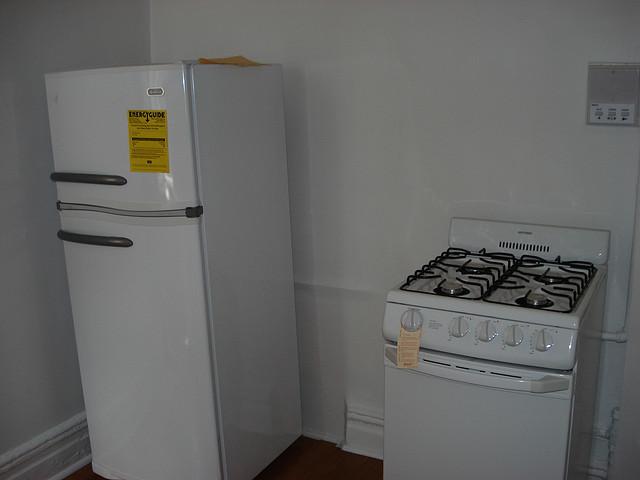Is the fridge door open?
Give a very brief answer. No. Why are these items tagged?
Short answer required. New. Are there a lot of magnets on the refrigerator?
Keep it brief. No. Do the items in the image resemble new appliances?
Keep it brief. Yes. Is this a modern style refrigerator?
Keep it brief. No. What is the yellow strip  on the oven?
Give a very brief answer. Tag. What room is this?
Answer briefly. Kitchen. Why are the tags on these appliances?
Short answer required. They are new. Does the stove have a cover lid?
Write a very short answer. No. What color is the floor?
Short answer required. Brown. What kind of fuel operates the stove?
Answer briefly. Gas. Are there magnets on the refrigerator?
Answer briefly. No. 